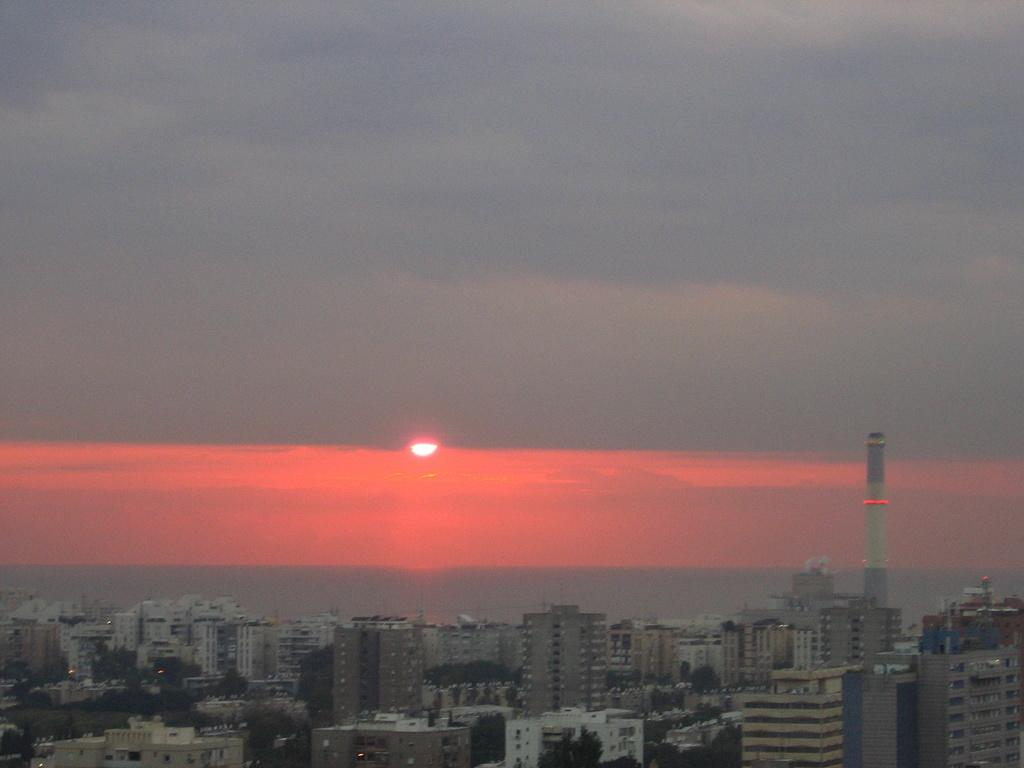What type of view is shown in the image? The image is an aerial view. What is the main subject of the aerial view? The aerial view is taken from above a building. How many buildings can be seen in the image? There are many buildings visible in the image. What time of day is depicted in the image? The sun is setting in the image. What type of owl can be seen nesting in one of the buildings in the image? There are no owls visible in the image, as it is an aerial view of buildings and not a nature scene. 